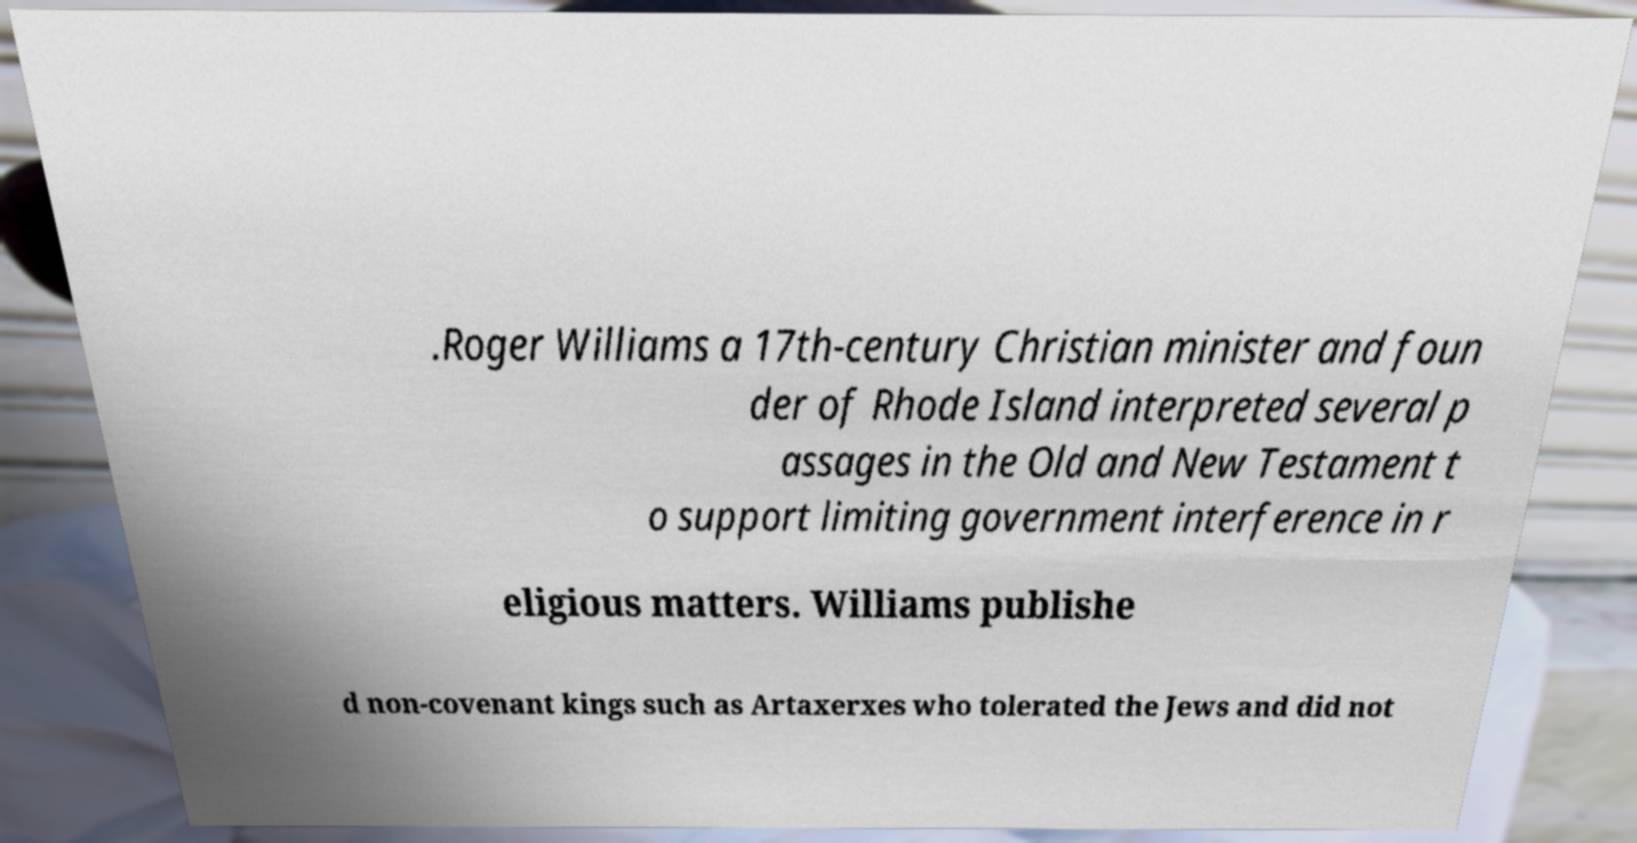Please identify and transcribe the text found in this image. .Roger Williams a 17th-century Christian minister and foun der of Rhode Island interpreted several p assages in the Old and New Testament t o support limiting government interference in r eligious matters. Williams publishe d non-covenant kings such as Artaxerxes who tolerated the Jews and did not 